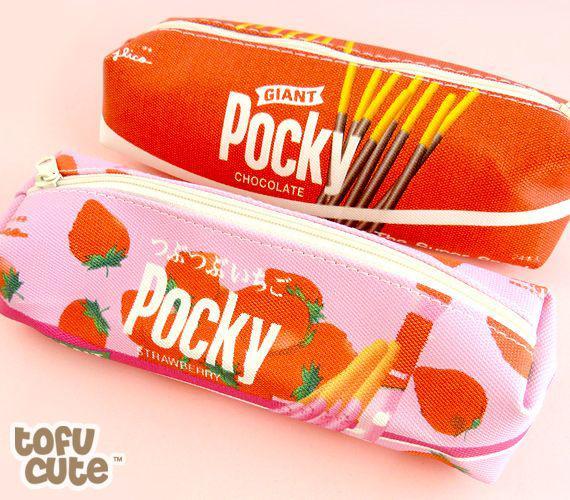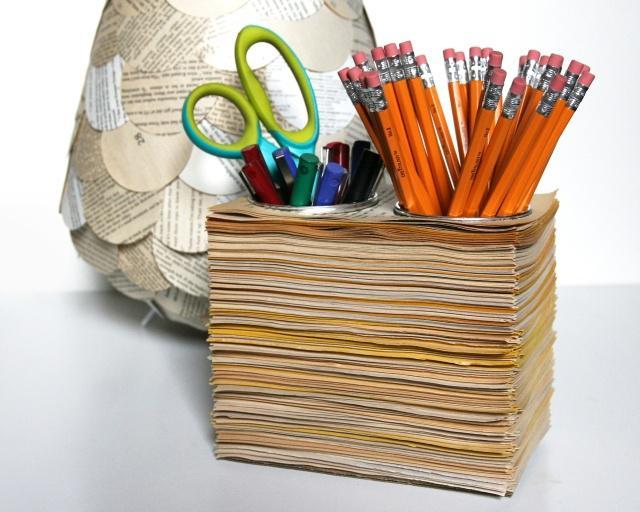The first image is the image on the left, the second image is the image on the right. Assess this claim about the two images: "There are no writing utensils visible in one of the pictures.". Correct or not? Answer yes or no. Yes. 